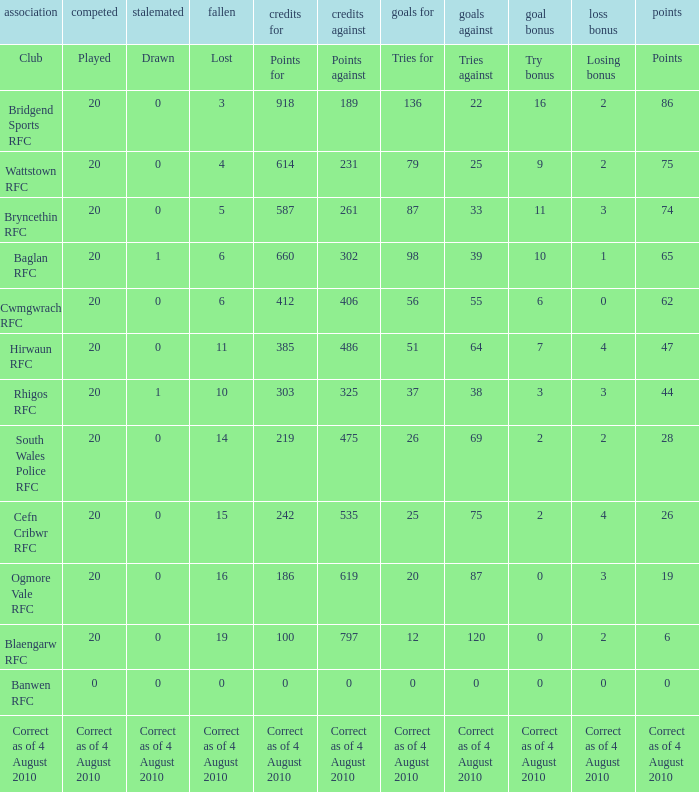What is the points against when drawn is drawn? Points against. 